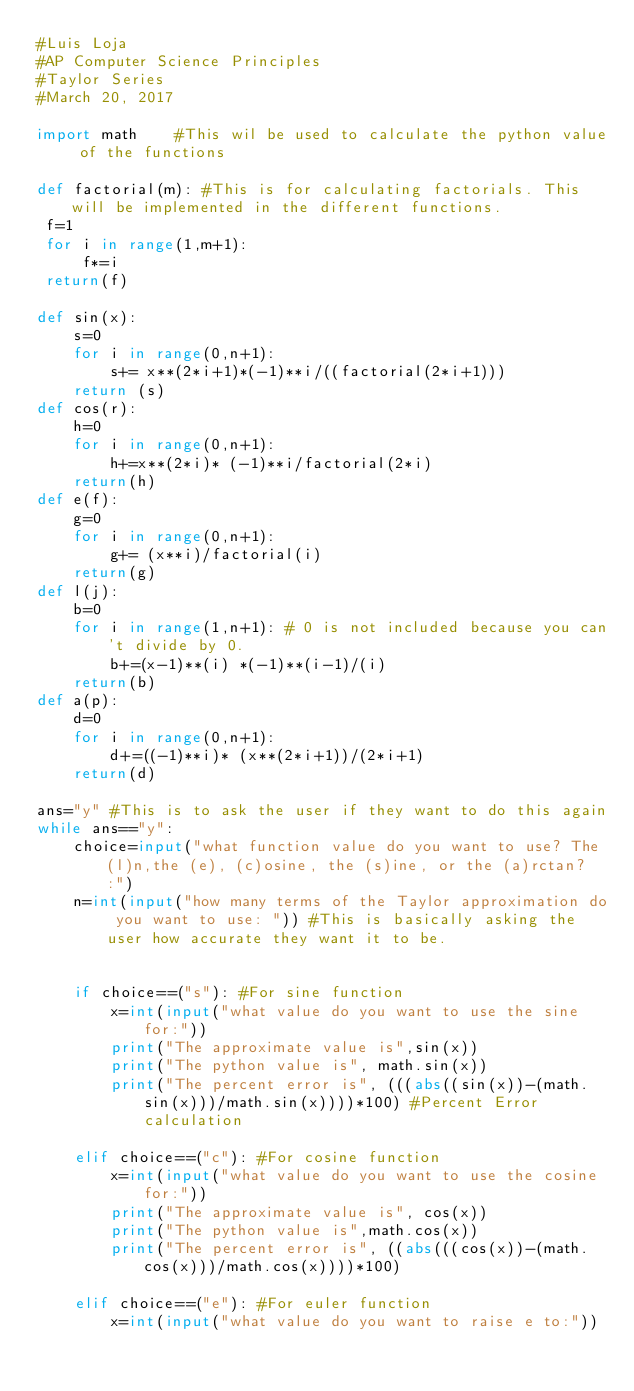Convert code to text. <code><loc_0><loc_0><loc_500><loc_500><_Python_>#Luis Loja
#AP Computer Science Principles
#Taylor Series
#March 20, 2017

import math    #This wil be used to calculate the python value of the functions

def factorial(m): #This is for calculating factorials. This will be implemented in the different functions. 
 f=1
 for i in range(1,m+1): 
     f*=i
 return(f)

def sin(x):    
    s=0
    for i in range(0,n+1):
        s+= x**(2*i+1)*(-1)**i/((factorial(2*i+1))) 
    return (s)
def cos(r):
    h=0
    for i in range(0,n+1):
        h+=x**(2*i)* (-1)**i/factorial(2*i)
    return(h)
def e(f):
    g=0
    for i in range(0,n+1):
        g+= (x**i)/factorial(i)
    return(g)
def l(j):
    b=0
    for i in range(1,n+1): # 0 is not included because you can't divide by 0.
        b+=(x-1)**(i) *(-1)**(i-1)/(i)
    return(b)
def a(p):
    d=0
    for i in range(0,n+1):
        d+=((-1)**i)* (x**(2*i+1))/(2*i+1)
    return(d)
    
ans="y" #This is to ask the user if they want to do this again
while ans=="y":
    choice=input("what function value do you want to use? The (l)n,the (e), (c)osine, the (s)ine, or the (a)rctan?  :")
    n=int(input("how many terms of the Taylor approximation do you want to use: ")) #This is basically asking the user how accurate they want it to be. 


    if choice==("s"): #For sine function
        x=int(input("what value do you want to use the sine for:"))
        print("The approximate value is",sin(x))
        print("The python value is", math.sin(x))
        print("The percent error is", (((abs((sin(x))-(math.sin(x)))/math.sin(x))))*100) #Percent Error calculation

    elif choice==("c"): #For cosine function
        x=int(input("what value do you want to use the cosine for:"))
        print("The approximate value is", cos(x))
        print("The python value is",math.cos(x))
        print("The percent error is", ((abs(((cos(x))-(math.cos(x)))/math.cos(x))))*100)

    elif choice==("e"): #For euler function
        x=int(input("what value do you want to raise e to:"))</code> 